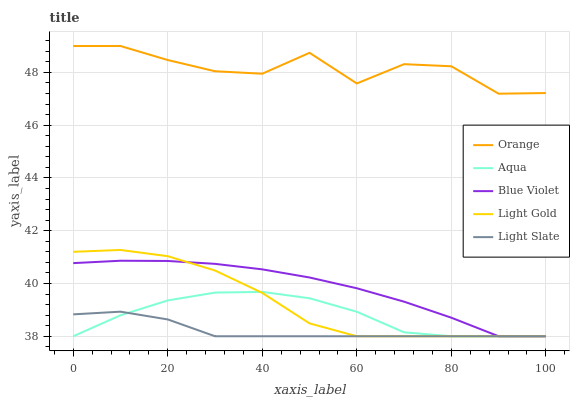Does Light Slate have the minimum area under the curve?
Answer yes or no. Yes. Does Orange have the maximum area under the curve?
Answer yes or no. Yes. Does Light Gold have the minimum area under the curve?
Answer yes or no. No. Does Light Gold have the maximum area under the curve?
Answer yes or no. No. Is Light Slate the smoothest?
Answer yes or no. Yes. Is Orange the roughest?
Answer yes or no. Yes. Is Light Gold the smoothest?
Answer yes or no. No. Is Light Gold the roughest?
Answer yes or no. No. Does Light Gold have the lowest value?
Answer yes or no. Yes. Does Orange have the highest value?
Answer yes or no. Yes. Does Light Gold have the highest value?
Answer yes or no. No. Is Light Gold less than Orange?
Answer yes or no. Yes. Is Orange greater than Light Slate?
Answer yes or no. Yes. Does Blue Violet intersect Light Gold?
Answer yes or no. Yes. Is Blue Violet less than Light Gold?
Answer yes or no. No. Is Blue Violet greater than Light Gold?
Answer yes or no. No. Does Light Gold intersect Orange?
Answer yes or no. No. 